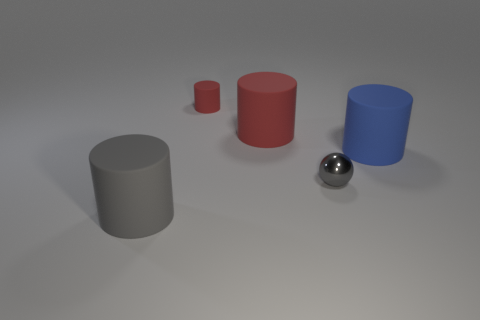Subtract all blue blocks. How many red cylinders are left? 2 Add 3 matte cylinders. How many objects exist? 8 Subtract all large blue cylinders. How many cylinders are left? 3 Subtract all gray cylinders. How many cylinders are left? 3 Subtract all cylinders. How many objects are left? 1 Subtract 1 cylinders. How many cylinders are left? 3 Subtract all green balls. Subtract all blue blocks. How many balls are left? 1 Subtract all gray matte cylinders. Subtract all red things. How many objects are left? 2 Add 2 big gray matte cylinders. How many big gray matte cylinders are left? 3 Add 5 gray rubber things. How many gray rubber things exist? 6 